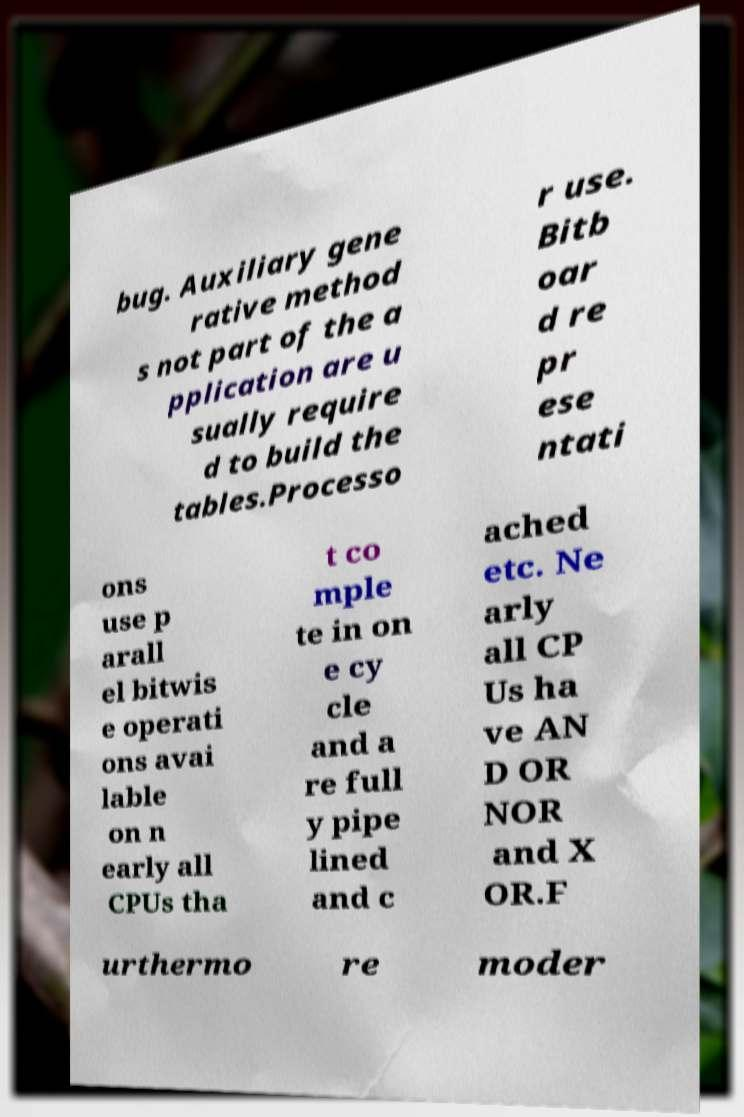Could you extract and type out the text from this image? bug. Auxiliary gene rative method s not part of the a pplication are u sually require d to build the tables.Processo r use. Bitb oar d re pr ese ntati ons use p arall el bitwis e operati ons avai lable on n early all CPUs tha t co mple te in on e cy cle and a re full y pipe lined and c ached etc. Ne arly all CP Us ha ve AN D OR NOR and X OR.F urthermo re moder 